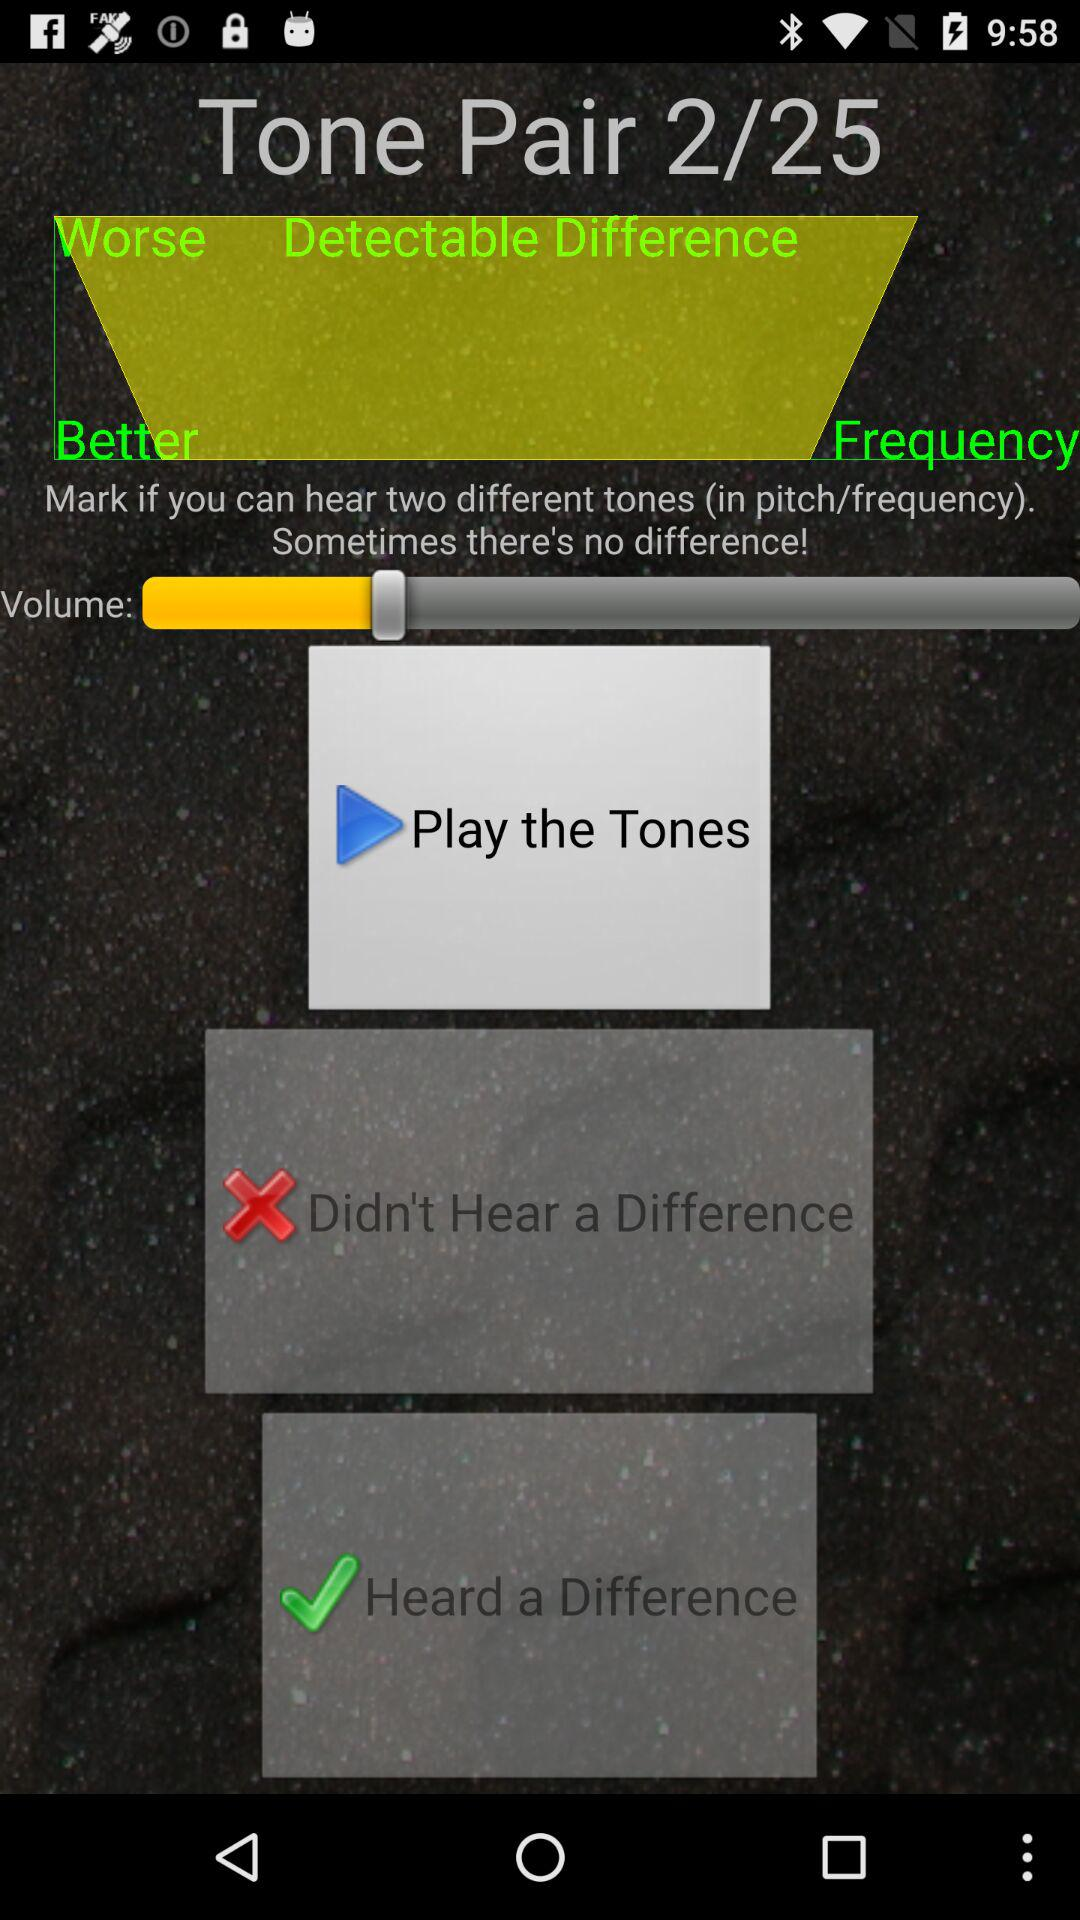What is the total number of tone pairs? The total number of tone pairs is 25. 